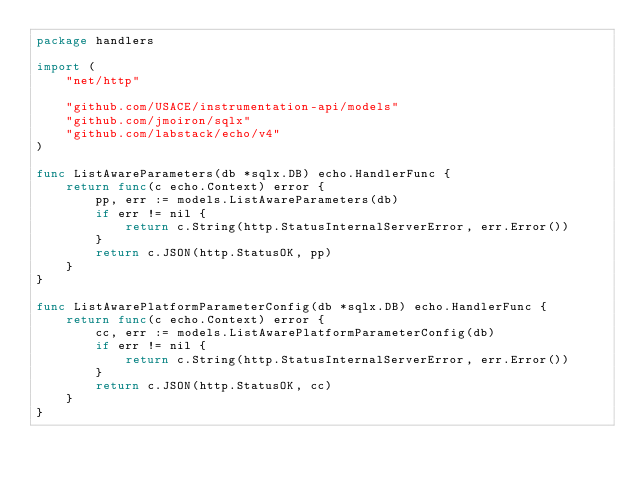Convert code to text. <code><loc_0><loc_0><loc_500><loc_500><_Go_>package handlers

import (
	"net/http"

	"github.com/USACE/instrumentation-api/models"
	"github.com/jmoiron/sqlx"
	"github.com/labstack/echo/v4"
)

func ListAwareParameters(db *sqlx.DB) echo.HandlerFunc {
	return func(c echo.Context) error {
		pp, err := models.ListAwareParameters(db)
		if err != nil {
			return c.String(http.StatusInternalServerError, err.Error())
		}
		return c.JSON(http.StatusOK, pp)
	}
}

func ListAwarePlatformParameterConfig(db *sqlx.DB) echo.HandlerFunc {
	return func(c echo.Context) error {
		cc, err := models.ListAwarePlatformParameterConfig(db)
		if err != nil {
			return c.String(http.StatusInternalServerError, err.Error())
		}
		return c.JSON(http.StatusOK, cc)
	}
}
</code> 